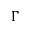Convert formula to latex. <formula><loc_0><loc_0><loc_500><loc_500>\Gamma</formula> 